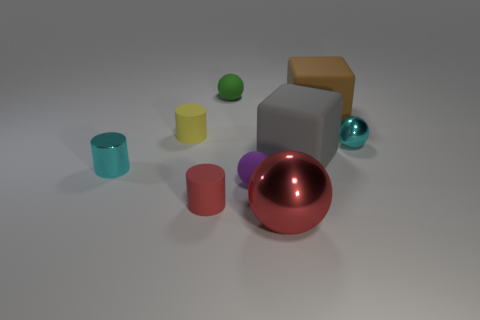What is the color of the cylinder that is made of the same material as the large ball? cyan 